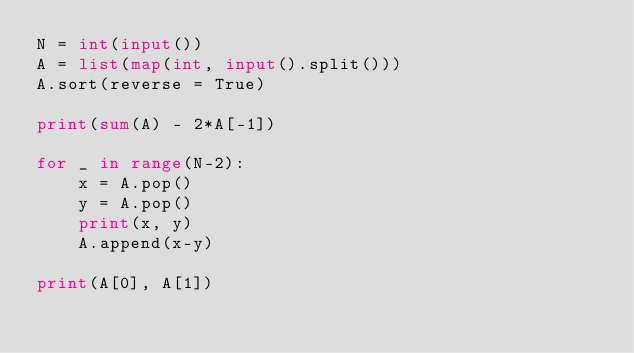<code> <loc_0><loc_0><loc_500><loc_500><_Python_>N = int(input())
A = list(map(int, input().split()))
A.sort(reverse = True)

print(sum(A) - 2*A[-1])

for _ in range(N-2):
    x = A.pop()
    y = A.pop()
    print(x, y)
    A.append(x-y)

print(A[0], A[1])</code> 